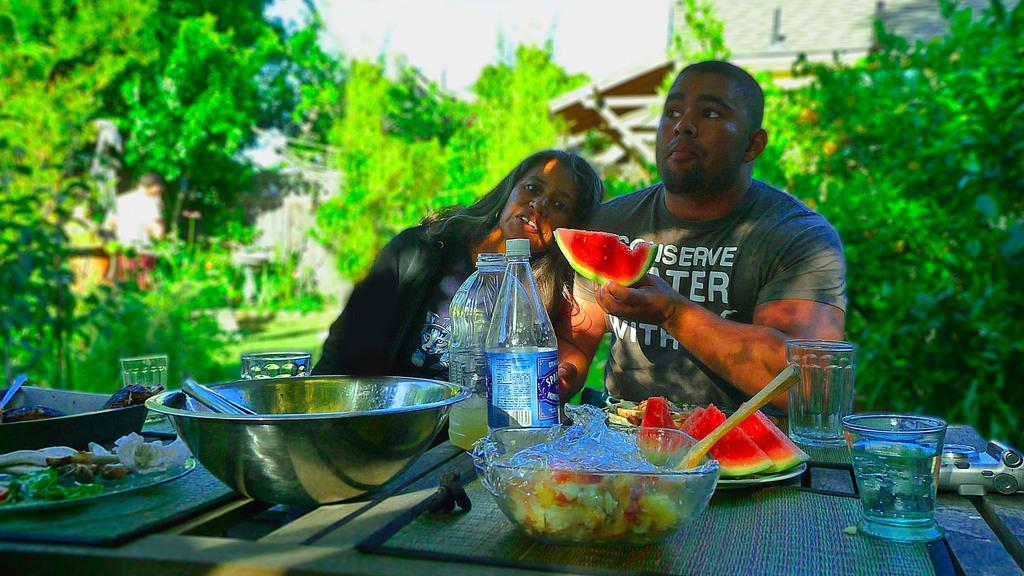How would you summarize this image in a sentence or two? A lady with black jacket is sitting beside a man with grey t-shirt, holding a piece of watermelon. IN front of them there is a table. On the table there is a bowl with food items, a glass, camera, plate, big bowl steel one, water bottles and spoons. In the background there are some trees and building. 